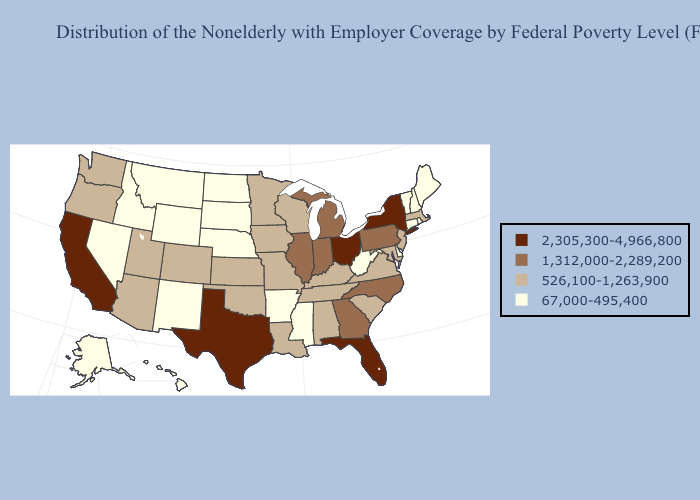What is the lowest value in states that border Oklahoma?
Short answer required. 67,000-495,400. Which states have the highest value in the USA?
Give a very brief answer. California, Florida, New York, Ohio, Texas. What is the lowest value in the South?
Short answer required. 67,000-495,400. Does Louisiana have the lowest value in the South?
Be succinct. No. What is the lowest value in states that border Montana?
Short answer required. 67,000-495,400. Does Alabama have the highest value in the USA?
Keep it brief. No. What is the value of Iowa?
Short answer required. 526,100-1,263,900. Among the states that border Texas , does Arkansas have the highest value?
Keep it brief. No. What is the value of Mississippi?
Be succinct. 67,000-495,400. Name the states that have a value in the range 1,312,000-2,289,200?
Be succinct. Georgia, Illinois, Indiana, Michigan, North Carolina, Pennsylvania. Name the states that have a value in the range 67,000-495,400?
Answer briefly. Alaska, Arkansas, Connecticut, Delaware, Hawaii, Idaho, Maine, Mississippi, Montana, Nebraska, Nevada, New Hampshire, New Mexico, North Dakota, Rhode Island, South Dakota, Vermont, West Virginia, Wyoming. What is the lowest value in states that border South Dakota?
Keep it brief. 67,000-495,400. Which states have the lowest value in the MidWest?
Short answer required. Nebraska, North Dakota, South Dakota. Does Maine have the lowest value in the USA?
Keep it brief. Yes. Does Tennessee have the same value as New York?
Short answer required. No. 